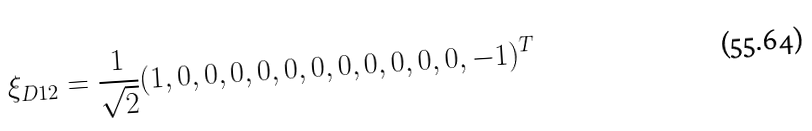Convert formula to latex. <formula><loc_0><loc_0><loc_500><loc_500>\xi _ { D 1 2 } = \frac { 1 } { \sqrt { 2 } } ( 1 , 0 , 0 , 0 , 0 , 0 , 0 , 0 , 0 , 0 , 0 , 0 , - 1 ) ^ { T }</formula> 